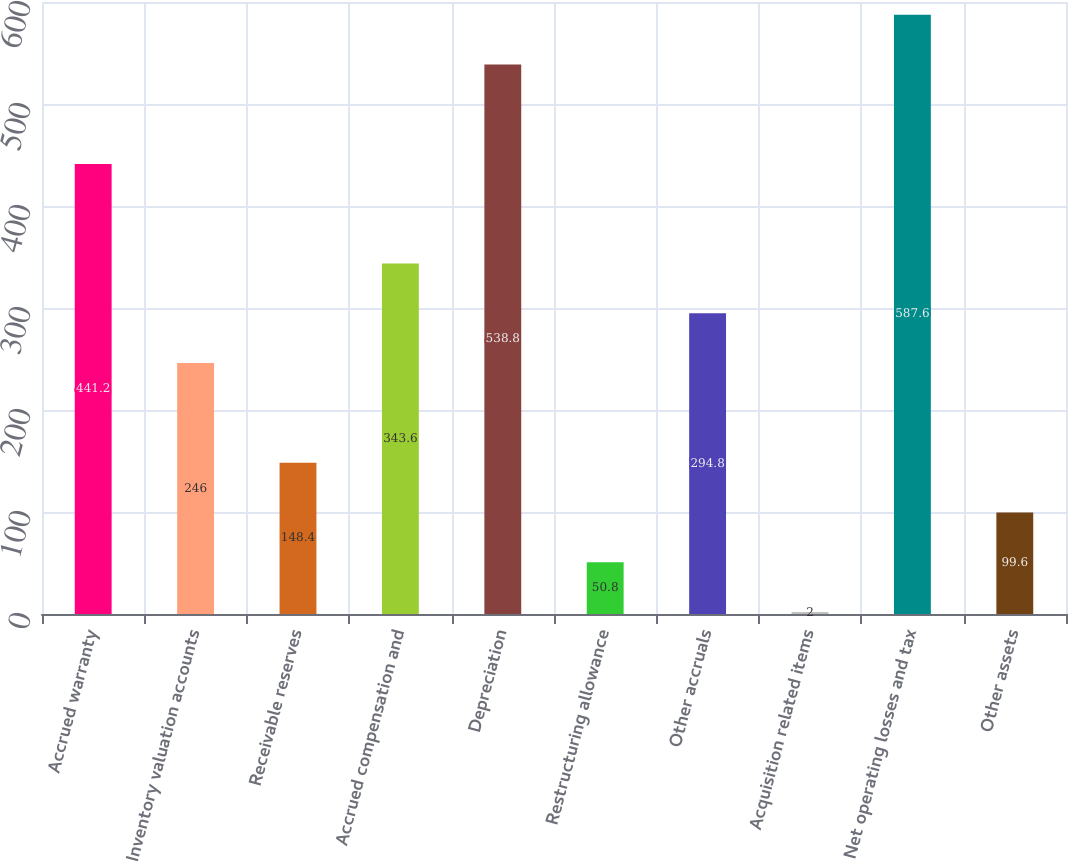Convert chart. <chart><loc_0><loc_0><loc_500><loc_500><bar_chart><fcel>Accrued warranty<fcel>Inventory valuation accounts<fcel>Receivable reserves<fcel>Accrued compensation and<fcel>Depreciation<fcel>Restructuring allowance<fcel>Other accruals<fcel>Acquisition related items<fcel>Net operating losses and tax<fcel>Other assets<nl><fcel>441.2<fcel>246<fcel>148.4<fcel>343.6<fcel>538.8<fcel>50.8<fcel>294.8<fcel>2<fcel>587.6<fcel>99.6<nl></chart> 